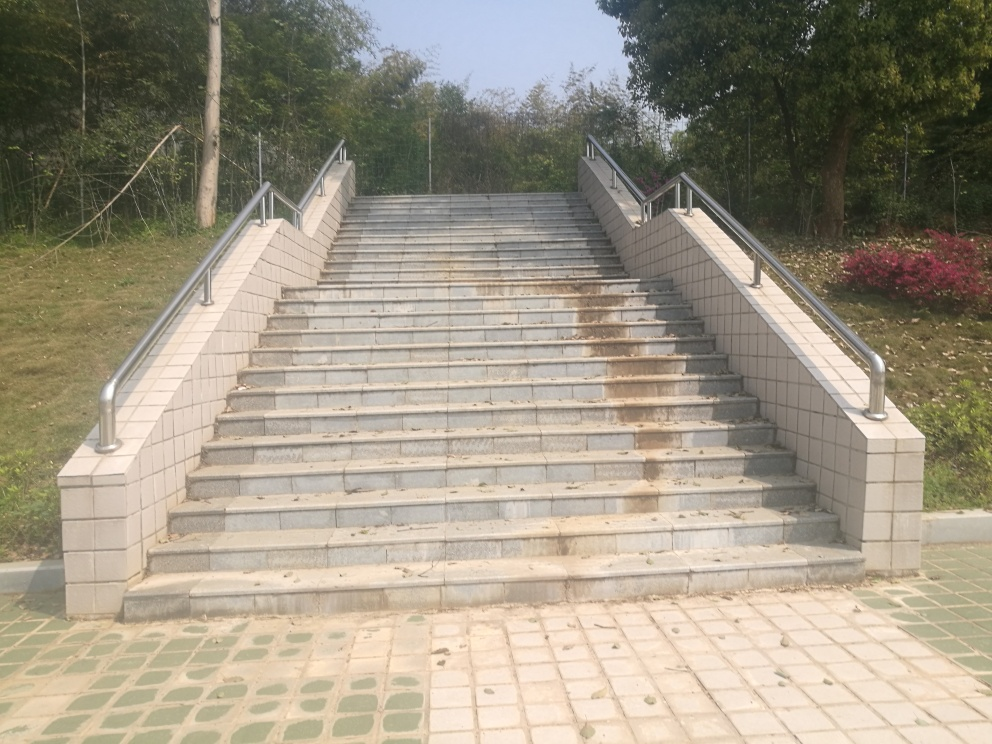Is this staircase designed to be accessible for individuals with disabilities? From the image, it's clear that the staircase itself is not wheelchair accessible due to the absence of a ramp. However, there are sturdy handrails on both sides, which can aid individuals who have the mobility to use stairs but require additional support. 